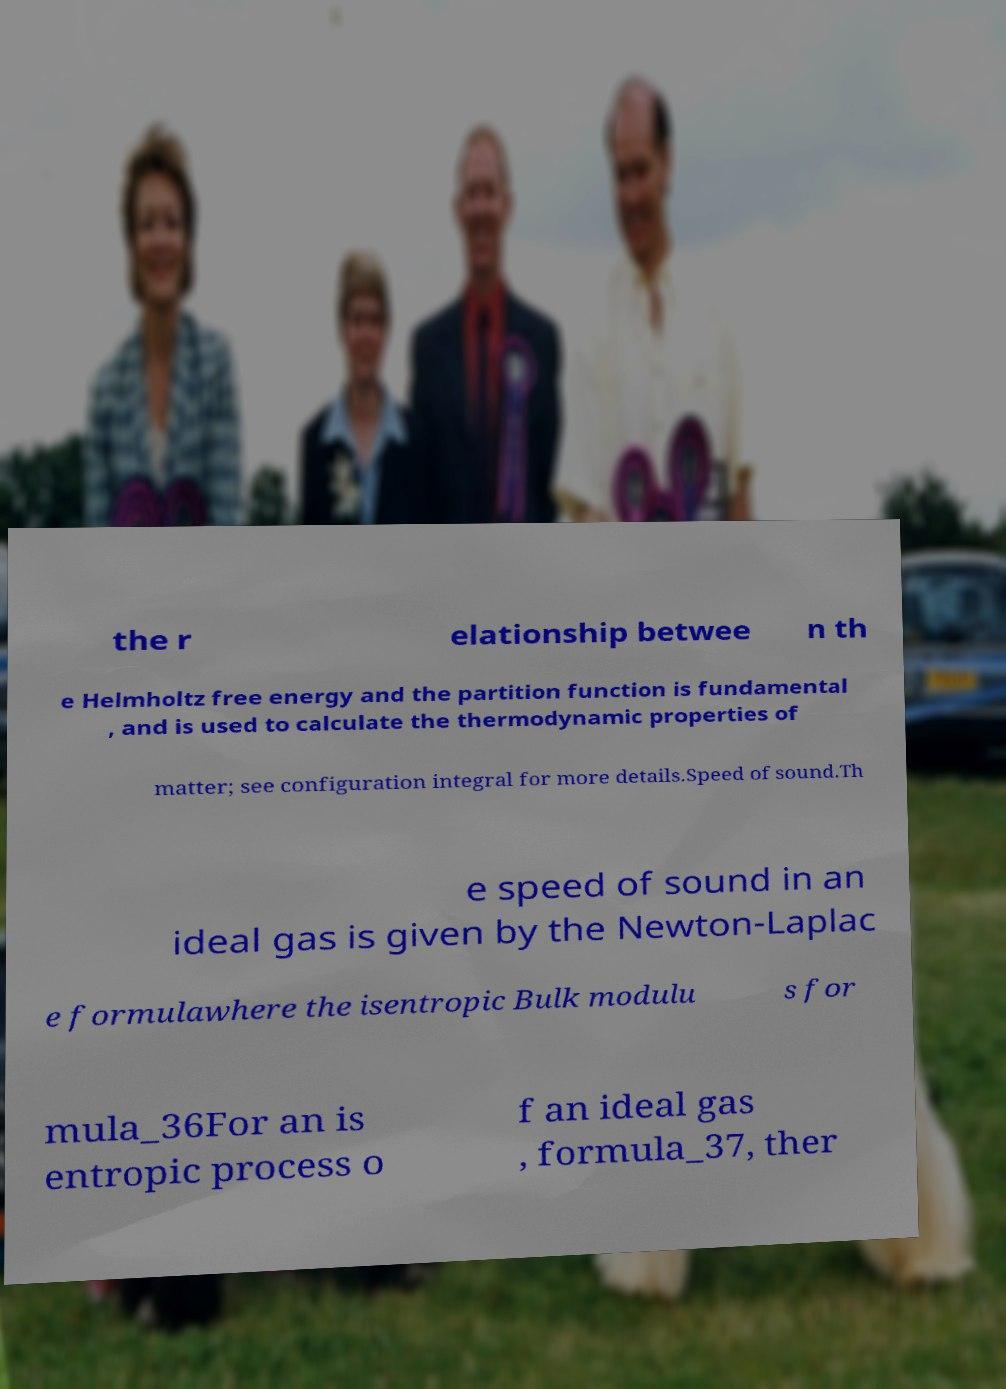I need the written content from this picture converted into text. Can you do that? the r elationship betwee n th e Helmholtz free energy and the partition function is fundamental , and is used to calculate the thermodynamic properties of matter; see configuration integral for more details.Speed of sound.Th e speed of sound in an ideal gas is given by the Newton-Laplac e formulawhere the isentropic Bulk modulu s for mula_36For an is entropic process o f an ideal gas , formula_37, ther 